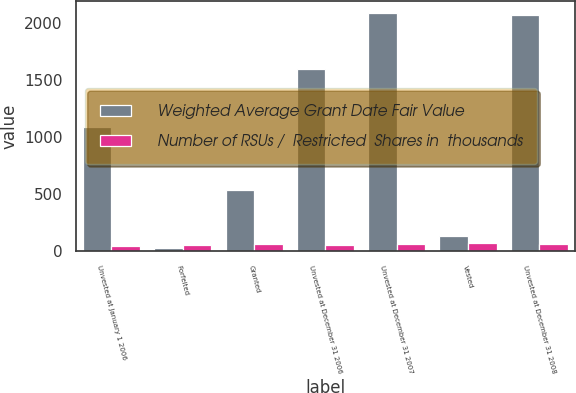<chart> <loc_0><loc_0><loc_500><loc_500><stacked_bar_chart><ecel><fcel>Unvested at January 1 2006<fcel>Forfeited<fcel>Granted<fcel>Unvested at December 31 2006<fcel>Unvested at December 31 2007<fcel>Vested<fcel>Unvested at December 31 2008<nl><fcel>Weighted Average Grant Date Fair Value<fcel>1091<fcel>30<fcel>536<fcel>1597<fcel>2081<fcel>136<fcel>2064<nl><fcel>Number of RSUs /  Restricted  Shares in  thousands<fcel>49.94<fcel>56.7<fcel>62.13<fcel>54.14<fcel>59.96<fcel>67.51<fcel>60.57<nl></chart> 